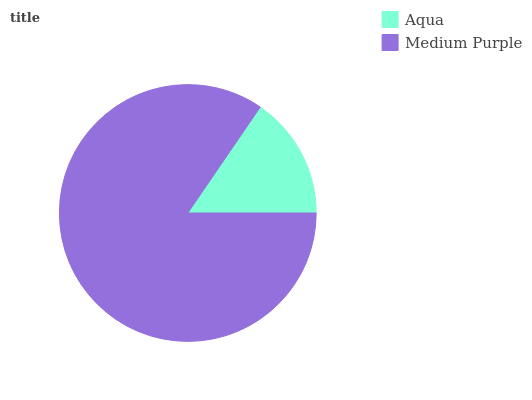Is Aqua the minimum?
Answer yes or no. Yes. Is Medium Purple the maximum?
Answer yes or no. Yes. Is Medium Purple the minimum?
Answer yes or no. No. Is Medium Purple greater than Aqua?
Answer yes or no. Yes. Is Aqua less than Medium Purple?
Answer yes or no. Yes. Is Aqua greater than Medium Purple?
Answer yes or no. No. Is Medium Purple less than Aqua?
Answer yes or no. No. Is Medium Purple the high median?
Answer yes or no. Yes. Is Aqua the low median?
Answer yes or no. Yes. Is Aqua the high median?
Answer yes or no. No. Is Medium Purple the low median?
Answer yes or no. No. 